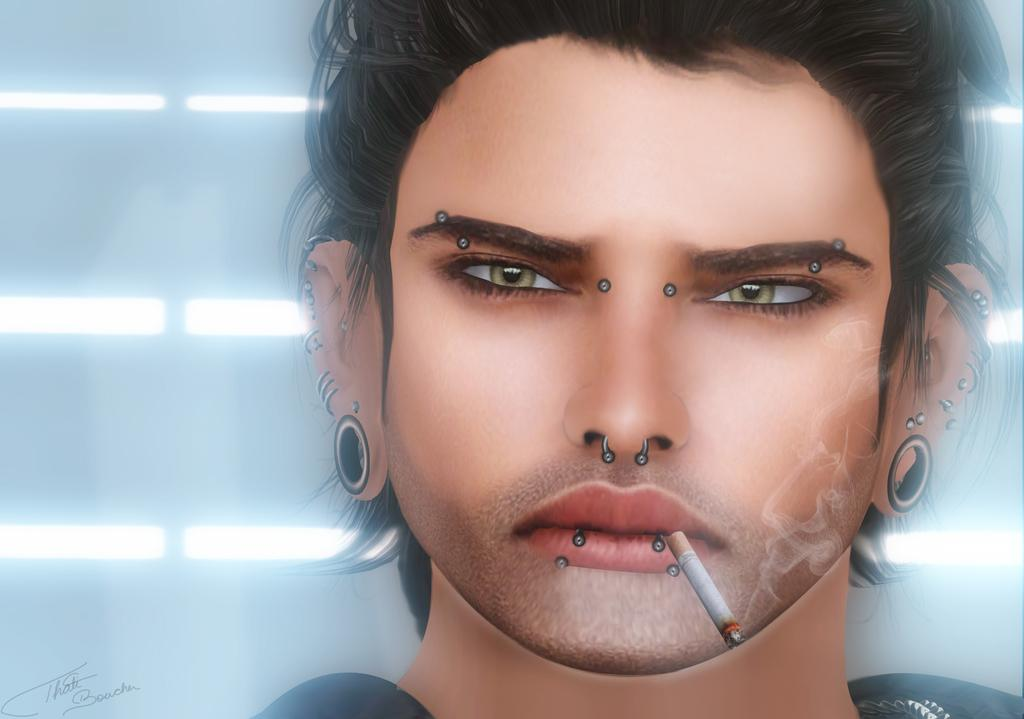What type of image is being described? The image is animated. What can be seen in the background of the image? There is a wall and lights in the background of the image. Who is the main subject in the image? There is a man in the middle of the image. What is the man doing in the image? The man is smoking. What type of fruit is hanging from the man's tail in the image? There is no fruit or tail present in the image; the man is smoking and there are no animals or tails mentioned. 